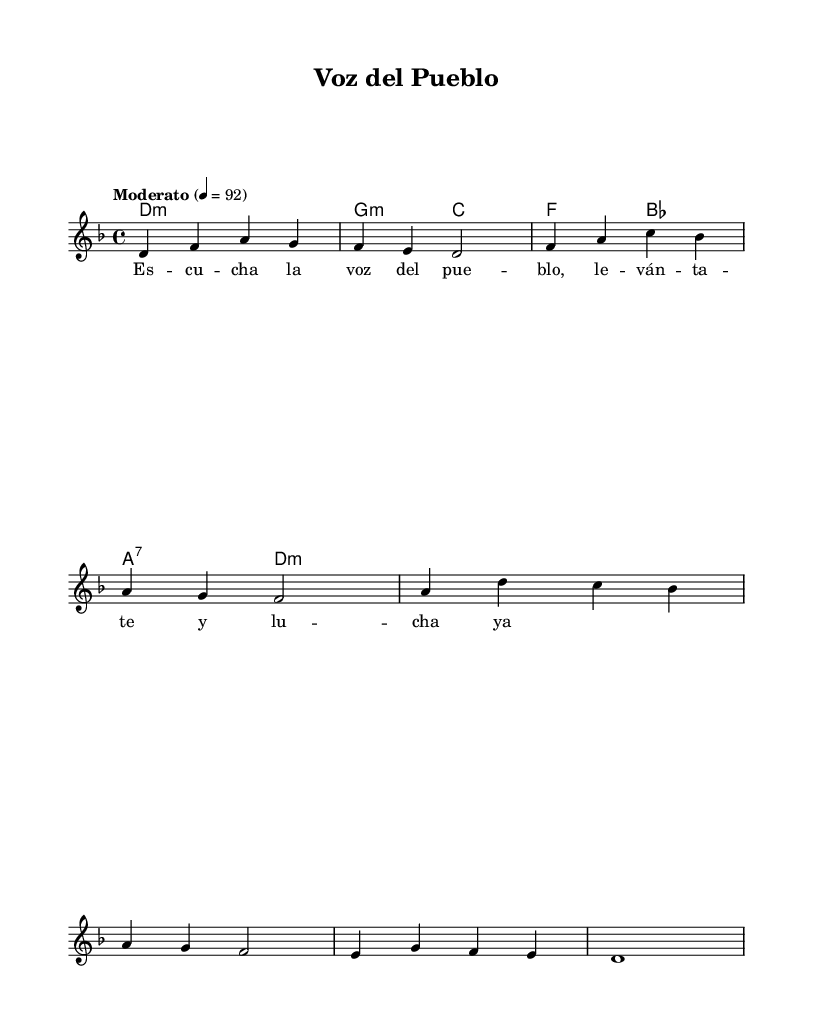What is the key signature of this music? The key signature is indicated by the key at the beginning of the staff, which shows one flat. This indicates the key of D minor.
Answer: D minor What is the time signature of this music? The time signature is shown at the beginning of the score, indicated as 4/4. This means there are four beats in each measure.
Answer: 4/4 What is the tempo marking of this piece? The tempo is marked at the beginning of the score, showing "Moderato" with a metronome marking of 92. This indicates the speed at which the piece should be played.
Answer: Moderato, 92 How many measures are in the melody? By counting the individual measures in the melody section, we find there are eight measures in total, each separated by a vertical line.
Answer: 8 What type of harmonies are used in this piece? The harmonies are written in chord mode, indicating the presence of minor and seventh chords. Specifically, D minor, G minor, C major, F major, B-flat, and A7 chords are used.
Answer: Minor and seventh chords What is the theme of the lyrics provided? The lyrics of the song "Voz del Pueblo" suggest themes of empowerment and collective action, as it calls to "listen to the voice of the people," which directly addresses social and political issues.
Answer: Empowerment and collective action Which section of the score displays the lyrics? The lyrics are displayed in the section labeled as "Lyrics," which is positioned below the melody line to correspond with the notes.
Answer: Lyrics section 